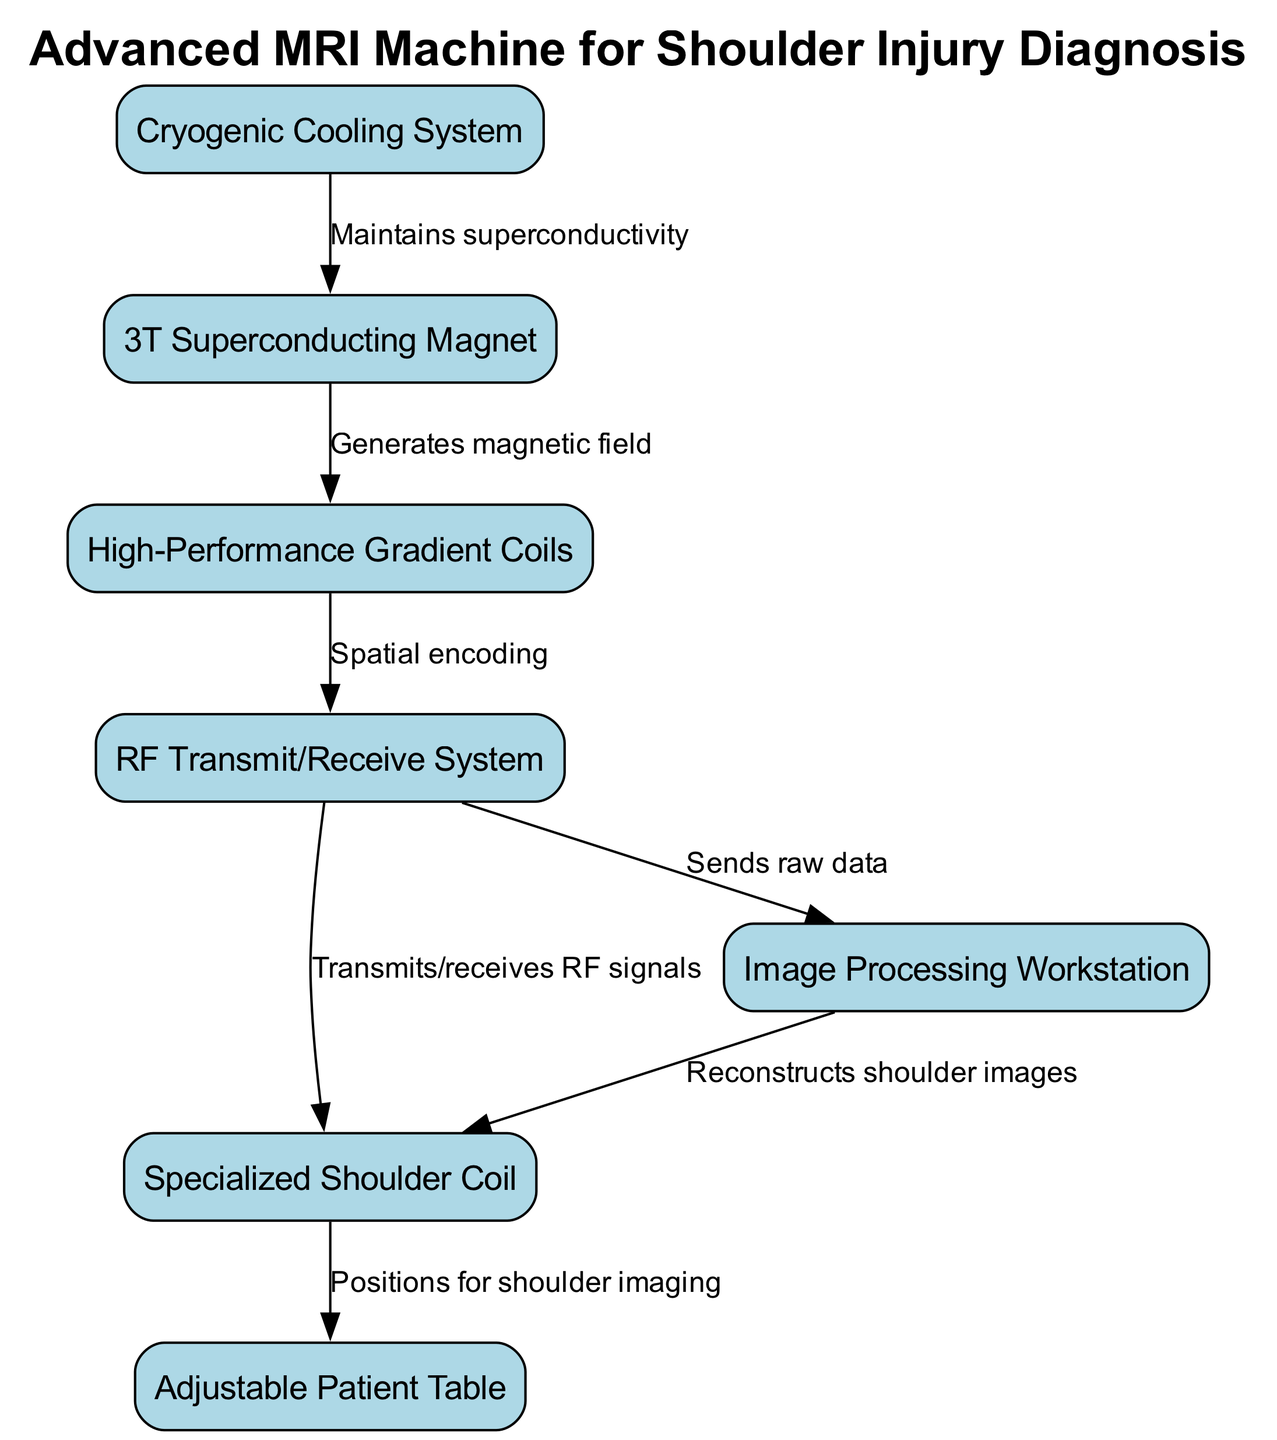What is the main component of the MRI machine? The diagram indicates that the primary component is the "3T Superconducting Magnet," which is labeled clearly as the significant structure of the machine.
Answer: 3T Superconducting Magnet How many nodes are in the diagram? By counting the individual elements in the nodes section of the diagram, there are a total of 7 distinct components, each representing different parts of the MRI machine.
Answer: 7 What is the function of the gradient coils? The edges show that the "High-Performance Gradient Coils" are connected to the "RF Transmit/Receive System" and are responsible for "Spatial encoding," thus defining their key role in the system.
Answer: Spatial encoding Which component receives RF signals from the RF system? The diagram specifies that the "Specialized Shoulder Coil" receives the RF signals sent from the "RF Transmit/Receive System," indicating its role in the process.
Answer: Specialized Shoulder Coil What maintains superconductivity for the main magnet? The diagram illustrates that the "Cryogenic Cooling System" maintains the superconductivity of the "3T Superconducting Magnet," which is critical for its operation.
Answer: Cryogenic Cooling System Which component is connected to both the RF system and the computer system? The edges in the diagram reveal that the "RF Transmit/Receive System" connects to both the "Specialized Shoulder Coil" and sends raw data to the "Image Processing Workstation," showcasing its dual connectivity.
Answer: RF Transmit/Receive System What does the computer system do with the data received? Following the flow indicated in the diagram, the "Image Processing Workstation" is responsible for reconstructing shoulder images based on the raw data received from the "RF Transmit/Receive System."
Answer: Reconstructs shoulder images How are patients positioned for imaging? The flow from the "Specialized Shoulder Coil" to the "Adjustable Patient Table" indicates that the patient table is where patients are positioned for shoulder imaging, highlighting its function in the process.
Answer: Positions for shoulder imaging 